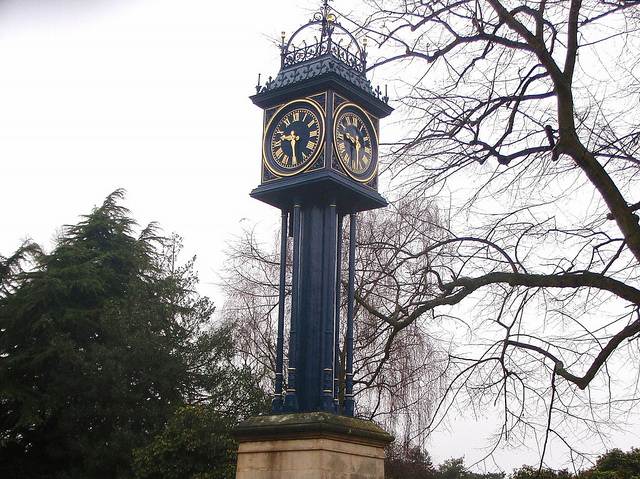What type of setting does this clock seem to be in? The clock stands in a serene setting, likely a public park or garden given the lush trees surrounding it. It seems well-placed to serve both an aesthetic and a functional purpose, providing an elegant timepiece for visitors and passersby to enjoy amidst the greenery. 